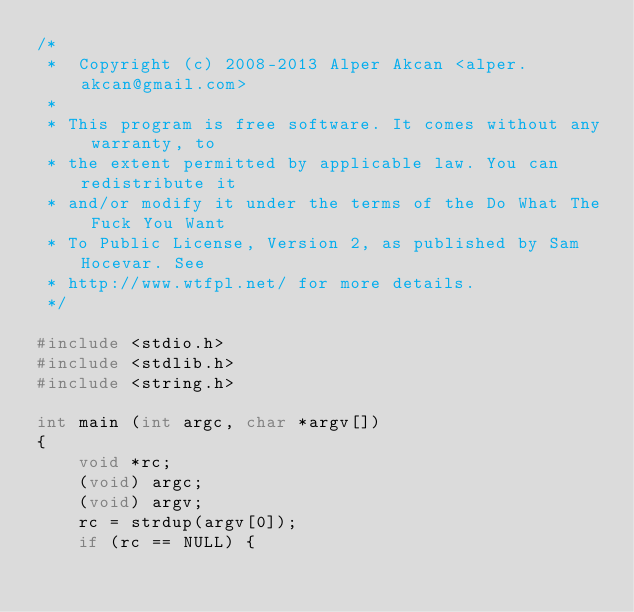Convert code to text. <code><loc_0><loc_0><loc_500><loc_500><_C_>/*
 *  Copyright (c) 2008-2013 Alper Akcan <alper.akcan@gmail.com>
 *
 * This program is free software. It comes without any warranty, to
 * the extent permitted by applicable law. You can redistribute it
 * and/or modify it under the terms of the Do What The Fuck You Want
 * To Public License, Version 2, as published by Sam Hocevar. See
 * http://www.wtfpl.net/ for more details.
 */

#include <stdio.h>
#include <stdlib.h>
#include <string.h>

int main (int argc, char *argv[])
{
	void *rc;
	(void) argc;
	(void) argv;
	rc = strdup(argv[0]);
	if (rc == NULL) {</code> 